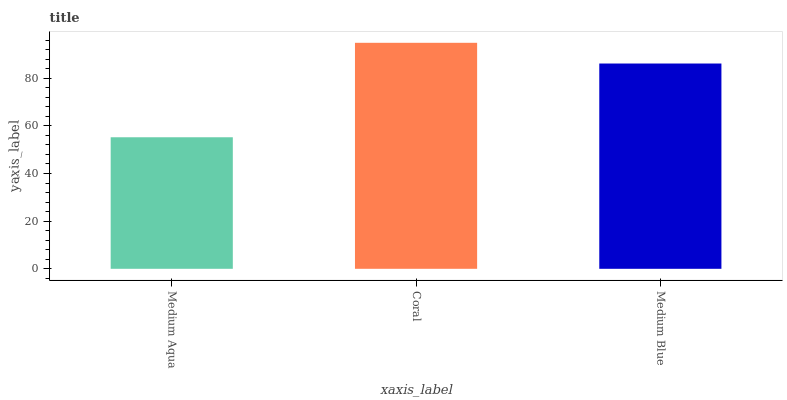Is Medium Blue the minimum?
Answer yes or no. No. Is Medium Blue the maximum?
Answer yes or no. No. Is Coral greater than Medium Blue?
Answer yes or no. Yes. Is Medium Blue less than Coral?
Answer yes or no. Yes. Is Medium Blue greater than Coral?
Answer yes or no. No. Is Coral less than Medium Blue?
Answer yes or no. No. Is Medium Blue the high median?
Answer yes or no. Yes. Is Medium Blue the low median?
Answer yes or no. Yes. Is Coral the high median?
Answer yes or no. No. Is Medium Aqua the low median?
Answer yes or no. No. 